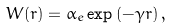Convert formula to latex. <formula><loc_0><loc_0><loc_500><loc_500>W ( r ) = \alpha _ { e } \exp \left ( - \gamma r \right ) ,</formula> 